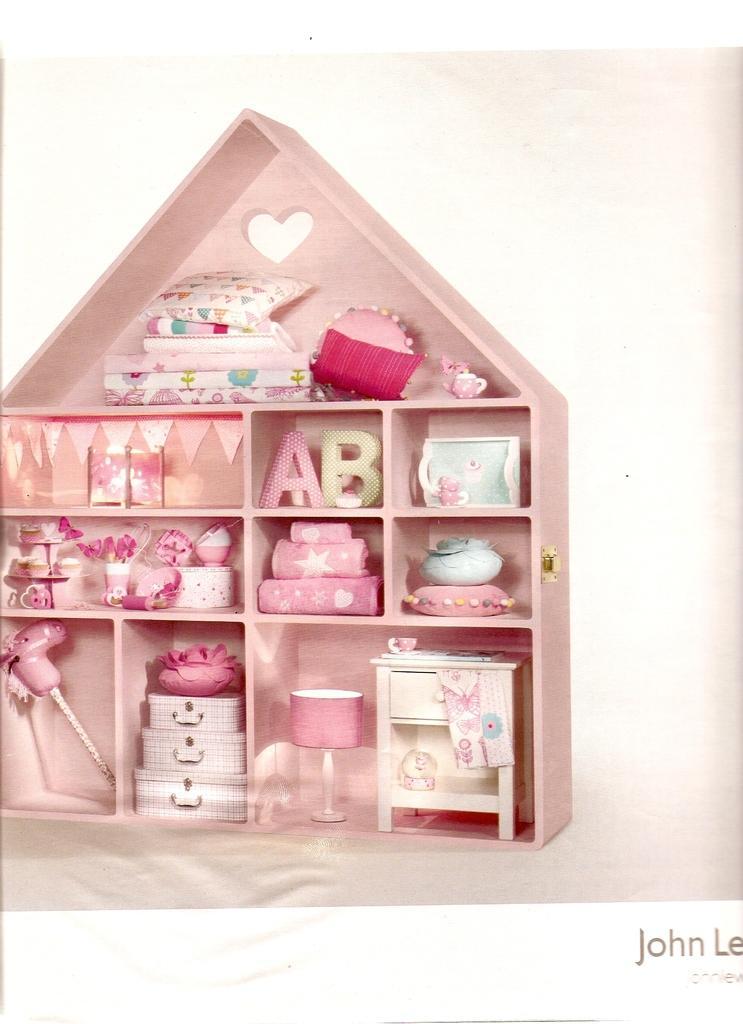Can you describe this image briefly? In this picture I can observe few objects placed in the shelf. Most of the objects are in pink color. The background is in white color. 